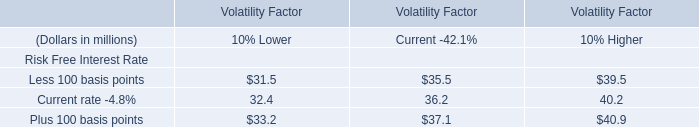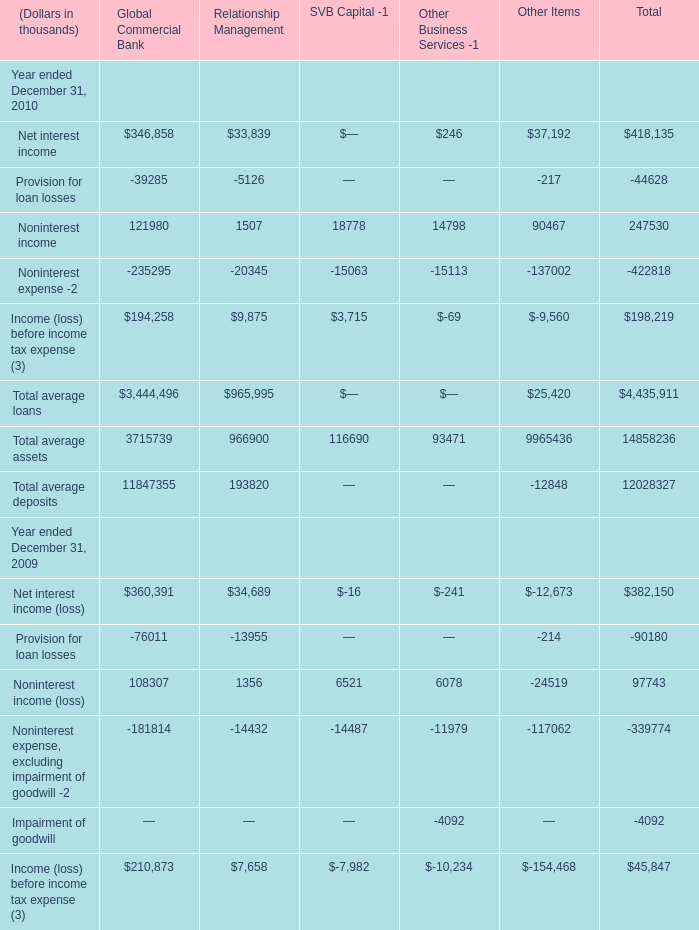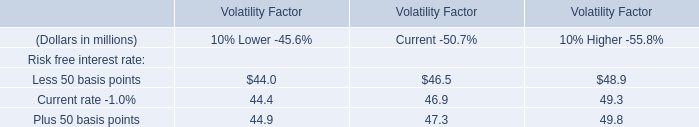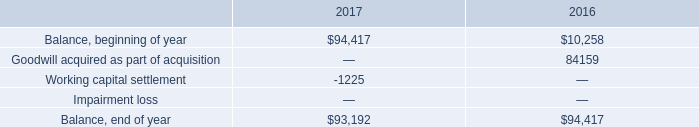What is the sum of Income (loss) before income tax expense in 2010 for Total? (in thousand) 
Computations: (((418135 - 44628) + 247530) - 422818)
Answer: 198219.0. 